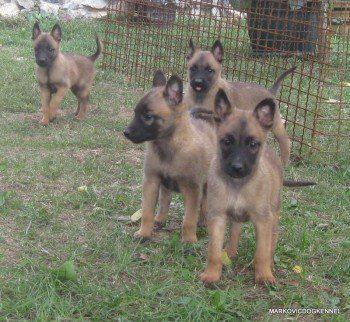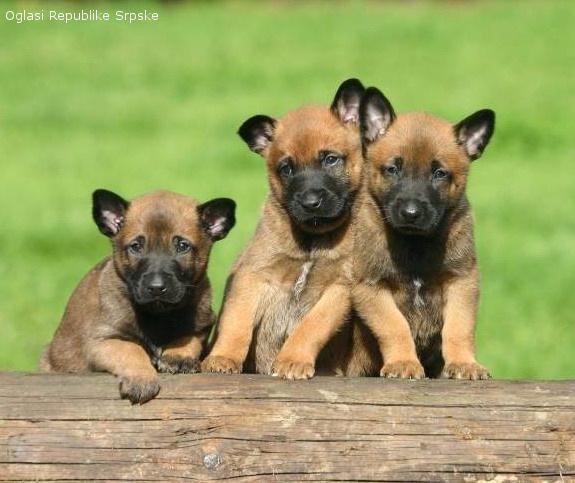The first image is the image on the left, the second image is the image on the right. Analyze the images presented: Is the assertion "Only german shepherd puppies are shown, and each image includes at least two puppies." valid? Answer yes or no. Yes. The first image is the image on the left, the second image is the image on the right. For the images displayed, is the sentence "There is no more than one dog in the left image." factually correct? Answer yes or no. No. 